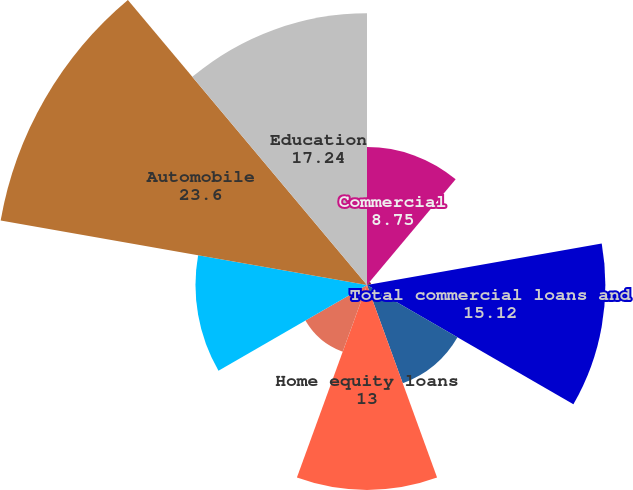<chart> <loc_0><loc_0><loc_500><loc_500><pie_chart><fcel>Commercial<fcel>Commercial real estate<fcel>Total commercial loans and<fcel>Residential mortgages<fcel>Home equity loans<fcel>Home equity lines of credit<fcel>Home equity loans serviced by<fcel>Automobile<fcel>Education<nl><fcel>8.75%<fcel>0.27%<fcel>15.12%<fcel>6.63%<fcel>13.0%<fcel>4.51%<fcel>10.88%<fcel>23.6%<fcel>17.24%<nl></chart> 